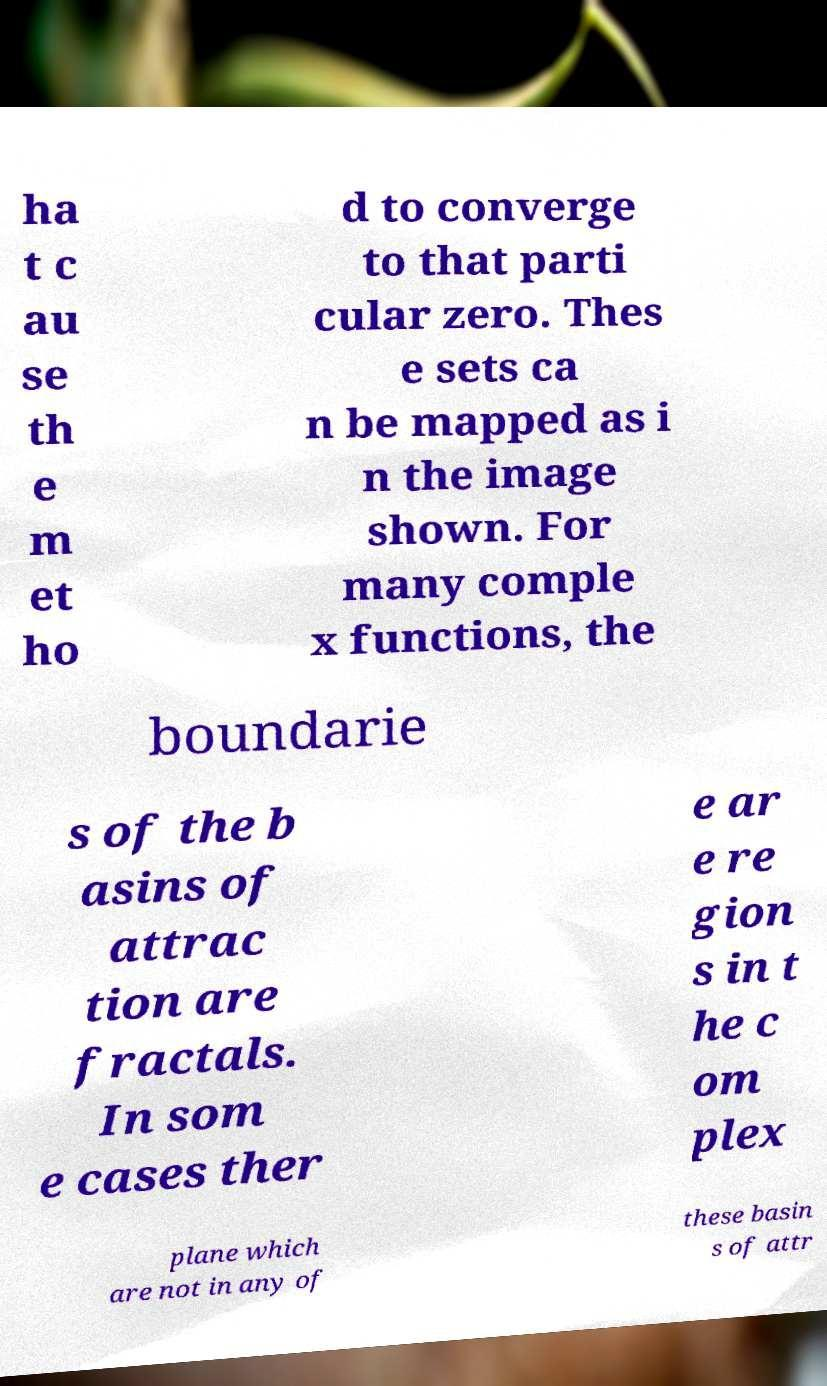Can you accurately transcribe the text from the provided image for me? ha t c au se th e m et ho d to converge to that parti cular zero. Thes e sets ca n be mapped as i n the image shown. For many comple x functions, the boundarie s of the b asins of attrac tion are fractals. In som e cases ther e ar e re gion s in t he c om plex plane which are not in any of these basin s of attr 